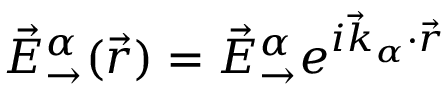<formula> <loc_0><loc_0><loc_500><loc_500>\vec { E } _ { \rightarrow } ^ { \alpha } ( \vec { r } ) = \vec { E } _ { \rightarrow } ^ { \alpha } e ^ { i \vec { k } _ { \alpha } \cdot \vec { r } }</formula> 